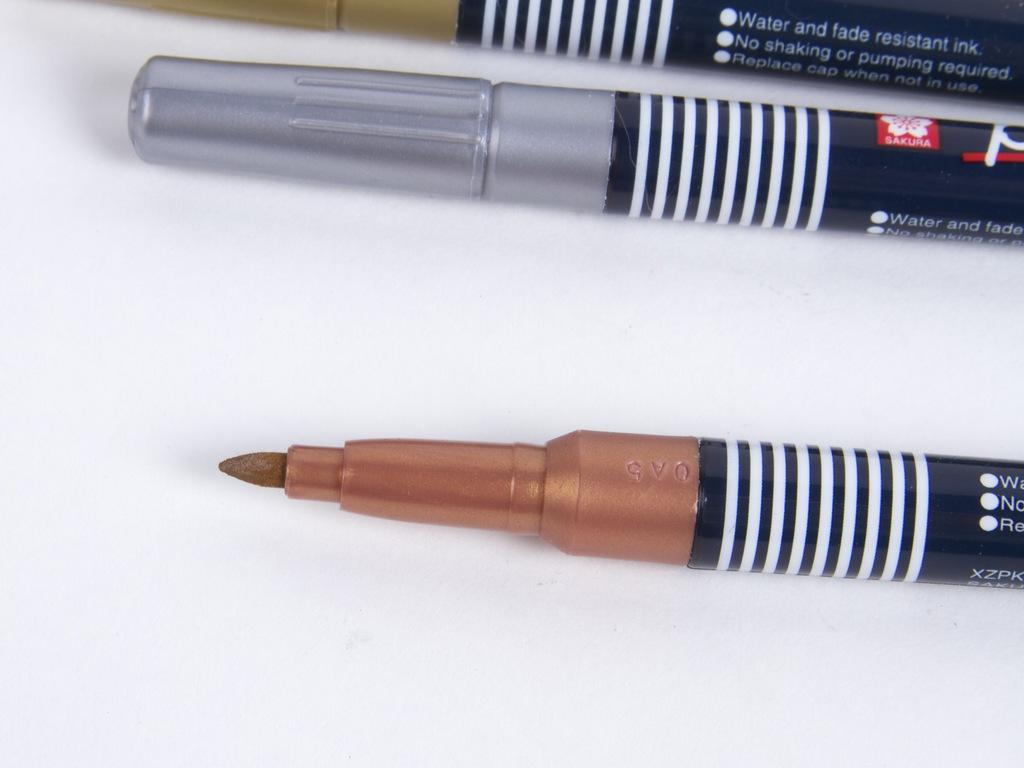What type of writing or drawing utensils are visible in the image? There are marker pens in the image. What type of cake is being decorated with the marker pens in the image? There is no cake present in the image; it only features marker pens. How many legs can be seen on the marker pens in the image? Marker pens do not have legs, so this question cannot be answered. 